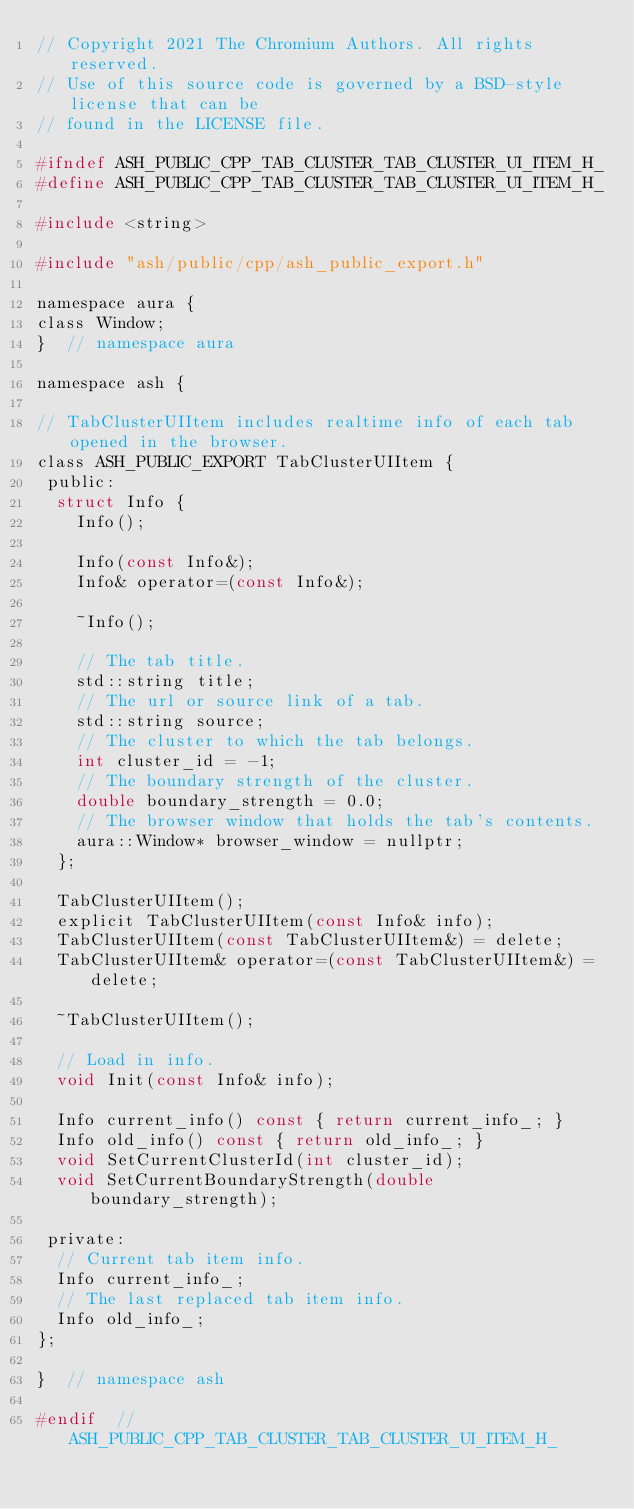Convert code to text. <code><loc_0><loc_0><loc_500><loc_500><_C_>// Copyright 2021 The Chromium Authors. All rights reserved.
// Use of this source code is governed by a BSD-style license that can be
// found in the LICENSE file.

#ifndef ASH_PUBLIC_CPP_TAB_CLUSTER_TAB_CLUSTER_UI_ITEM_H_
#define ASH_PUBLIC_CPP_TAB_CLUSTER_TAB_CLUSTER_UI_ITEM_H_

#include <string>

#include "ash/public/cpp/ash_public_export.h"

namespace aura {
class Window;
}  // namespace aura

namespace ash {

// TabClusterUIItem includes realtime info of each tab opened in the browser.
class ASH_PUBLIC_EXPORT TabClusterUIItem {
 public:
  struct Info {
    Info();

    Info(const Info&);
    Info& operator=(const Info&);

    ~Info();

    // The tab title.
    std::string title;
    // The url or source link of a tab.
    std::string source;
    // The cluster to which the tab belongs.
    int cluster_id = -1;
    // The boundary strength of the cluster.
    double boundary_strength = 0.0;
    // The browser window that holds the tab's contents.
    aura::Window* browser_window = nullptr;
  };

  TabClusterUIItem();
  explicit TabClusterUIItem(const Info& info);
  TabClusterUIItem(const TabClusterUIItem&) = delete;
  TabClusterUIItem& operator=(const TabClusterUIItem&) = delete;

  ~TabClusterUIItem();

  // Load in info.
  void Init(const Info& info);

  Info current_info() const { return current_info_; }
  Info old_info() const { return old_info_; }
  void SetCurrentClusterId(int cluster_id);
  void SetCurrentBoundaryStrength(double boundary_strength);

 private:
  // Current tab item info.
  Info current_info_;
  // The last replaced tab item info.
  Info old_info_;
};

}  // namespace ash

#endif  // ASH_PUBLIC_CPP_TAB_CLUSTER_TAB_CLUSTER_UI_ITEM_H_
</code> 